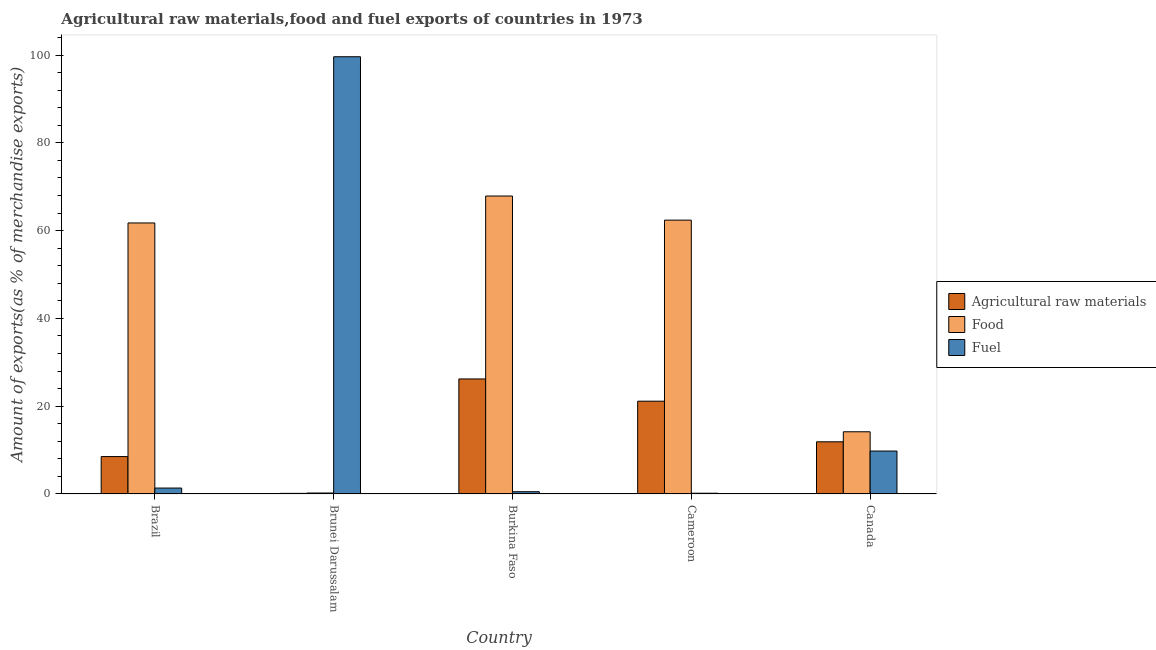How many different coloured bars are there?
Your answer should be compact. 3. Are the number of bars per tick equal to the number of legend labels?
Your answer should be very brief. Yes. Are the number of bars on each tick of the X-axis equal?
Make the answer very short. Yes. How many bars are there on the 1st tick from the left?
Your answer should be compact. 3. What is the label of the 3rd group of bars from the left?
Keep it short and to the point. Burkina Faso. In how many cases, is the number of bars for a given country not equal to the number of legend labels?
Ensure brevity in your answer.  0. What is the percentage of raw materials exports in Brunei Darussalam?
Your response must be concise. 0.14. Across all countries, what is the maximum percentage of food exports?
Ensure brevity in your answer.  67.88. Across all countries, what is the minimum percentage of food exports?
Give a very brief answer. 0.22. In which country was the percentage of food exports maximum?
Make the answer very short. Burkina Faso. In which country was the percentage of raw materials exports minimum?
Your answer should be compact. Brunei Darussalam. What is the total percentage of raw materials exports in the graph?
Your response must be concise. 67.89. What is the difference between the percentage of raw materials exports in Brunei Darussalam and that in Cameroon?
Make the answer very short. -21. What is the difference between the percentage of food exports in Brunei Darussalam and the percentage of raw materials exports in Brazil?
Offer a terse response. -8.3. What is the average percentage of fuel exports per country?
Provide a short and direct response. 22.29. What is the difference between the percentage of fuel exports and percentage of raw materials exports in Cameroon?
Give a very brief answer. -20.97. In how many countries, is the percentage of raw materials exports greater than 20 %?
Offer a very short reply. 2. What is the ratio of the percentage of food exports in Brazil to that in Brunei Darussalam?
Ensure brevity in your answer.  283.7. Is the difference between the percentage of raw materials exports in Brazil and Burkina Faso greater than the difference between the percentage of fuel exports in Brazil and Burkina Faso?
Ensure brevity in your answer.  No. What is the difference between the highest and the second highest percentage of fuel exports?
Provide a succinct answer. 89.83. What is the difference between the highest and the lowest percentage of food exports?
Ensure brevity in your answer.  67.66. In how many countries, is the percentage of food exports greater than the average percentage of food exports taken over all countries?
Give a very brief answer. 3. Is the sum of the percentage of food exports in Brazil and Canada greater than the maximum percentage of fuel exports across all countries?
Provide a short and direct response. No. What does the 3rd bar from the left in Brazil represents?
Provide a succinct answer. Fuel. What does the 2nd bar from the right in Canada represents?
Make the answer very short. Food. Is it the case that in every country, the sum of the percentage of raw materials exports and percentage of food exports is greater than the percentage of fuel exports?
Provide a succinct answer. No. How many bars are there?
Your answer should be very brief. 15. Are all the bars in the graph horizontal?
Make the answer very short. No. What is the difference between two consecutive major ticks on the Y-axis?
Make the answer very short. 20. Are the values on the major ticks of Y-axis written in scientific E-notation?
Make the answer very short. No. Does the graph contain any zero values?
Your answer should be very brief. No. Does the graph contain grids?
Offer a very short reply. No. Where does the legend appear in the graph?
Give a very brief answer. Center right. How many legend labels are there?
Make the answer very short. 3. What is the title of the graph?
Offer a very short reply. Agricultural raw materials,food and fuel exports of countries in 1973. What is the label or title of the Y-axis?
Your answer should be very brief. Amount of exports(as % of merchandise exports). What is the Amount of exports(as % of merchandise exports) in Agricultural raw materials in Brazil?
Offer a very short reply. 8.52. What is the Amount of exports(as % of merchandise exports) in Food in Brazil?
Provide a short and direct response. 61.74. What is the Amount of exports(as % of merchandise exports) in Fuel in Brazil?
Your answer should be compact. 1.35. What is the Amount of exports(as % of merchandise exports) of Agricultural raw materials in Brunei Darussalam?
Your answer should be very brief. 0.14. What is the Amount of exports(as % of merchandise exports) of Food in Brunei Darussalam?
Your response must be concise. 0.22. What is the Amount of exports(as % of merchandise exports) of Fuel in Brunei Darussalam?
Offer a very short reply. 99.61. What is the Amount of exports(as % of merchandise exports) in Agricultural raw materials in Burkina Faso?
Provide a short and direct response. 26.21. What is the Amount of exports(as % of merchandise exports) of Food in Burkina Faso?
Your answer should be compact. 67.88. What is the Amount of exports(as % of merchandise exports) in Fuel in Burkina Faso?
Your answer should be very brief. 0.52. What is the Amount of exports(as % of merchandise exports) in Agricultural raw materials in Cameroon?
Make the answer very short. 21.14. What is the Amount of exports(as % of merchandise exports) in Food in Cameroon?
Your answer should be compact. 62.39. What is the Amount of exports(as % of merchandise exports) in Fuel in Cameroon?
Make the answer very short. 0.17. What is the Amount of exports(as % of merchandise exports) in Agricultural raw materials in Canada?
Provide a succinct answer. 11.88. What is the Amount of exports(as % of merchandise exports) in Food in Canada?
Offer a terse response. 14.17. What is the Amount of exports(as % of merchandise exports) in Fuel in Canada?
Make the answer very short. 9.78. Across all countries, what is the maximum Amount of exports(as % of merchandise exports) of Agricultural raw materials?
Provide a succinct answer. 26.21. Across all countries, what is the maximum Amount of exports(as % of merchandise exports) in Food?
Offer a very short reply. 67.88. Across all countries, what is the maximum Amount of exports(as % of merchandise exports) in Fuel?
Your answer should be compact. 99.61. Across all countries, what is the minimum Amount of exports(as % of merchandise exports) of Agricultural raw materials?
Make the answer very short. 0.14. Across all countries, what is the minimum Amount of exports(as % of merchandise exports) in Food?
Make the answer very short. 0.22. Across all countries, what is the minimum Amount of exports(as % of merchandise exports) in Fuel?
Provide a succinct answer. 0.17. What is the total Amount of exports(as % of merchandise exports) in Agricultural raw materials in the graph?
Make the answer very short. 67.89. What is the total Amount of exports(as % of merchandise exports) in Food in the graph?
Keep it short and to the point. 206.4. What is the total Amount of exports(as % of merchandise exports) in Fuel in the graph?
Provide a succinct answer. 111.43. What is the difference between the Amount of exports(as % of merchandise exports) of Agricultural raw materials in Brazil and that in Brunei Darussalam?
Ensure brevity in your answer.  8.38. What is the difference between the Amount of exports(as % of merchandise exports) of Food in Brazil and that in Brunei Darussalam?
Your answer should be compact. 61.53. What is the difference between the Amount of exports(as % of merchandise exports) of Fuel in Brazil and that in Brunei Darussalam?
Offer a terse response. -98.27. What is the difference between the Amount of exports(as % of merchandise exports) of Agricultural raw materials in Brazil and that in Burkina Faso?
Your response must be concise. -17.69. What is the difference between the Amount of exports(as % of merchandise exports) of Food in Brazil and that in Burkina Faso?
Offer a very short reply. -6.14. What is the difference between the Amount of exports(as % of merchandise exports) of Fuel in Brazil and that in Burkina Faso?
Provide a succinct answer. 0.83. What is the difference between the Amount of exports(as % of merchandise exports) of Agricultural raw materials in Brazil and that in Cameroon?
Provide a succinct answer. -12.62. What is the difference between the Amount of exports(as % of merchandise exports) of Food in Brazil and that in Cameroon?
Keep it short and to the point. -0.64. What is the difference between the Amount of exports(as % of merchandise exports) of Fuel in Brazil and that in Cameroon?
Your answer should be very brief. 1.18. What is the difference between the Amount of exports(as % of merchandise exports) of Agricultural raw materials in Brazil and that in Canada?
Provide a succinct answer. -3.36. What is the difference between the Amount of exports(as % of merchandise exports) in Food in Brazil and that in Canada?
Offer a very short reply. 47.57. What is the difference between the Amount of exports(as % of merchandise exports) of Fuel in Brazil and that in Canada?
Keep it short and to the point. -8.43. What is the difference between the Amount of exports(as % of merchandise exports) of Agricultural raw materials in Brunei Darussalam and that in Burkina Faso?
Give a very brief answer. -26.07. What is the difference between the Amount of exports(as % of merchandise exports) in Food in Brunei Darussalam and that in Burkina Faso?
Your answer should be very brief. -67.66. What is the difference between the Amount of exports(as % of merchandise exports) of Fuel in Brunei Darussalam and that in Burkina Faso?
Keep it short and to the point. 99.1. What is the difference between the Amount of exports(as % of merchandise exports) in Agricultural raw materials in Brunei Darussalam and that in Cameroon?
Your answer should be compact. -21. What is the difference between the Amount of exports(as % of merchandise exports) in Food in Brunei Darussalam and that in Cameroon?
Offer a very short reply. -62.17. What is the difference between the Amount of exports(as % of merchandise exports) of Fuel in Brunei Darussalam and that in Cameroon?
Offer a terse response. 99.44. What is the difference between the Amount of exports(as % of merchandise exports) of Agricultural raw materials in Brunei Darussalam and that in Canada?
Offer a very short reply. -11.75. What is the difference between the Amount of exports(as % of merchandise exports) in Food in Brunei Darussalam and that in Canada?
Your response must be concise. -13.95. What is the difference between the Amount of exports(as % of merchandise exports) in Fuel in Brunei Darussalam and that in Canada?
Make the answer very short. 89.83. What is the difference between the Amount of exports(as % of merchandise exports) in Agricultural raw materials in Burkina Faso and that in Cameroon?
Give a very brief answer. 5.07. What is the difference between the Amount of exports(as % of merchandise exports) in Food in Burkina Faso and that in Cameroon?
Make the answer very short. 5.49. What is the difference between the Amount of exports(as % of merchandise exports) of Fuel in Burkina Faso and that in Cameroon?
Your answer should be compact. 0.35. What is the difference between the Amount of exports(as % of merchandise exports) of Agricultural raw materials in Burkina Faso and that in Canada?
Make the answer very short. 14.32. What is the difference between the Amount of exports(as % of merchandise exports) in Food in Burkina Faso and that in Canada?
Your answer should be compact. 53.71. What is the difference between the Amount of exports(as % of merchandise exports) of Fuel in Burkina Faso and that in Canada?
Offer a very short reply. -9.27. What is the difference between the Amount of exports(as % of merchandise exports) of Agricultural raw materials in Cameroon and that in Canada?
Provide a succinct answer. 9.25. What is the difference between the Amount of exports(as % of merchandise exports) of Food in Cameroon and that in Canada?
Keep it short and to the point. 48.22. What is the difference between the Amount of exports(as % of merchandise exports) in Fuel in Cameroon and that in Canada?
Your response must be concise. -9.61. What is the difference between the Amount of exports(as % of merchandise exports) of Agricultural raw materials in Brazil and the Amount of exports(as % of merchandise exports) of Food in Brunei Darussalam?
Give a very brief answer. 8.3. What is the difference between the Amount of exports(as % of merchandise exports) of Agricultural raw materials in Brazil and the Amount of exports(as % of merchandise exports) of Fuel in Brunei Darussalam?
Ensure brevity in your answer.  -91.09. What is the difference between the Amount of exports(as % of merchandise exports) of Food in Brazil and the Amount of exports(as % of merchandise exports) of Fuel in Brunei Darussalam?
Provide a short and direct response. -37.87. What is the difference between the Amount of exports(as % of merchandise exports) in Agricultural raw materials in Brazil and the Amount of exports(as % of merchandise exports) in Food in Burkina Faso?
Your answer should be compact. -59.36. What is the difference between the Amount of exports(as % of merchandise exports) in Agricultural raw materials in Brazil and the Amount of exports(as % of merchandise exports) in Fuel in Burkina Faso?
Offer a terse response. 8.01. What is the difference between the Amount of exports(as % of merchandise exports) in Food in Brazil and the Amount of exports(as % of merchandise exports) in Fuel in Burkina Faso?
Your response must be concise. 61.23. What is the difference between the Amount of exports(as % of merchandise exports) in Agricultural raw materials in Brazil and the Amount of exports(as % of merchandise exports) in Food in Cameroon?
Give a very brief answer. -53.87. What is the difference between the Amount of exports(as % of merchandise exports) of Agricultural raw materials in Brazil and the Amount of exports(as % of merchandise exports) of Fuel in Cameroon?
Ensure brevity in your answer.  8.35. What is the difference between the Amount of exports(as % of merchandise exports) of Food in Brazil and the Amount of exports(as % of merchandise exports) of Fuel in Cameroon?
Give a very brief answer. 61.57. What is the difference between the Amount of exports(as % of merchandise exports) in Agricultural raw materials in Brazil and the Amount of exports(as % of merchandise exports) in Food in Canada?
Ensure brevity in your answer.  -5.65. What is the difference between the Amount of exports(as % of merchandise exports) in Agricultural raw materials in Brazil and the Amount of exports(as % of merchandise exports) in Fuel in Canada?
Your answer should be compact. -1.26. What is the difference between the Amount of exports(as % of merchandise exports) of Food in Brazil and the Amount of exports(as % of merchandise exports) of Fuel in Canada?
Provide a short and direct response. 51.96. What is the difference between the Amount of exports(as % of merchandise exports) of Agricultural raw materials in Brunei Darussalam and the Amount of exports(as % of merchandise exports) of Food in Burkina Faso?
Your answer should be compact. -67.74. What is the difference between the Amount of exports(as % of merchandise exports) of Agricultural raw materials in Brunei Darussalam and the Amount of exports(as % of merchandise exports) of Fuel in Burkina Faso?
Your answer should be compact. -0.38. What is the difference between the Amount of exports(as % of merchandise exports) in Food in Brunei Darussalam and the Amount of exports(as % of merchandise exports) in Fuel in Burkina Faso?
Ensure brevity in your answer.  -0.3. What is the difference between the Amount of exports(as % of merchandise exports) in Agricultural raw materials in Brunei Darussalam and the Amount of exports(as % of merchandise exports) in Food in Cameroon?
Your answer should be compact. -62.25. What is the difference between the Amount of exports(as % of merchandise exports) in Agricultural raw materials in Brunei Darussalam and the Amount of exports(as % of merchandise exports) in Fuel in Cameroon?
Offer a very short reply. -0.03. What is the difference between the Amount of exports(as % of merchandise exports) of Food in Brunei Darussalam and the Amount of exports(as % of merchandise exports) of Fuel in Cameroon?
Give a very brief answer. 0.05. What is the difference between the Amount of exports(as % of merchandise exports) of Agricultural raw materials in Brunei Darussalam and the Amount of exports(as % of merchandise exports) of Food in Canada?
Offer a very short reply. -14.04. What is the difference between the Amount of exports(as % of merchandise exports) of Agricultural raw materials in Brunei Darussalam and the Amount of exports(as % of merchandise exports) of Fuel in Canada?
Make the answer very short. -9.64. What is the difference between the Amount of exports(as % of merchandise exports) of Food in Brunei Darussalam and the Amount of exports(as % of merchandise exports) of Fuel in Canada?
Your answer should be very brief. -9.56. What is the difference between the Amount of exports(as % of merchandise exports) in Agricultural raw materials in Burkina Faso and the Amount of exports(as % of merchandise exports) in Food in Cameroon?
Make the answer very short. -36.18. What is the difference between the Amount of exports(as % of merchandise exports) of Agricultural raw materials in Burkina Faso and the Amount of exports(as % of merchandise exports) of Fuel in Cameroon?
Keep it short and to the point. 26.04. What is the difference between the Amount of exports(as % of merchandise exports) in Food in Burkina Faso and the Amount of exports(as % of merchandise exports) in Fuel in Cameroon?
Offer a very short reply. 67.71. What is the difference between the Amount of exports(as % of merchandise exports) of Agricultural raw materials in Burkina Faso and the Amount of exports(as % of merchandise exports) of Food in Canada?
Keep it short and to the point. 12.04. What is the difference between the Amount of exports(as % of merchandise exports) of Agricultural raw materials in Burkina Faso and the Amount of exports(as % of merchandise exports) of Fuel in Canada?
Offer a very short reply. 16.43. What is the difference between the Amount of exports(as % of merchandise exports) of Food in Burkina Faso and the Amount of exports(as % of merchandise exports) of Fuel in Canada?
Provide a short and direct response. 58.1. What is the difference between the Amount of exports(as % of merchandise exports) of Agricultural raw materials in Cameroon and the Amount of exports(as % of merchandise exports) of Food in Canada?
Give a very brief answer. 6.97. What is the difference between the Amount of exports(as % of merchandise exports) of Agricultural raw materials in Cameroon and the Amount of exports(as % of merchandise exports) of Fuel in Canada?
Make the answer very short. 11.36. What is the difference between the Amount of exports(as % of merchandise exports) of Food in Cameroon and the Amount of exports(as % of merchandise exports) of Fuel in Canada?
Offer a very short reply. 52.61. What is the average Amount of exports(as % of merchandise exports) of Agricultural raw materials per country?
Make the answer very short. 13.58. What is the average Amount of exports(as % of merchandise exports) in Food per country?
Your response must be concise. 41.28. What is the average Amount of exports(as % of merchandise exports) of Fuel per country?
Your answer should be very brief. 22.29. What is the difference between the Amount of exports(as % of merchandise exports) in Agricultural raw materials and Amount of exports(as % of merchandise exports) in Food in Brazil?
Keep it short and to the point. -53.22. What is the difference between the Amount of exports(as % of merchandise exports) in Agricultural raw materials and Amount of exports(as % of merchandise exports) in Fuel in Brazil?
Your response must be concise. 7.17. What is the difference between the Amount of exports(as % of merchandise exports) in Food and Amount of exports(as % of merchandise exports) in Fuel in Brazil?
Offer a terse response. 60.4. What is the difference between the Amount of exports(as % of merchandise exports) of Agricultural raw materials and Amount of exports(as % of merchandise exports) of Food in Brunei Darussalam?
Offer a terse response. -0.08. What is the difference between the Amount of exports(as % of merchandise exports) in Agricultural raw materials and Amount of exports(as % of merchandise exports) in Fuel in Brunei Darussalam?
Provide a short and direct response. -99.48. What is the difference between the Amount of exports(as % of merchandise exports) of Food and Amount of exports(as % of merchandise exports) of Fuel in Brunei Darussalam?
Give a very brief answer. -99.4. What is the difference between the Amount of exports(as % of merchandise exports) in Agricultural raw materials and Amount of exports(as % of merchandise exports) in Food in Burkina Faso?
Ensure brevity in your answer.  -41.67. What is the difference between the Amount of exports(as % of merchandise exports) in Agricultural raw materials and Amount of exports(as % of merchandise exports) in Fuel in Burkina Faso?
Make the answer very short. 25.69. What is the difference between the Amount of exports(as % of merchandise exports) of Food and Amount of exports(as % of merchandise exports) of Fuel in Burkina Faso?
Your answer should be compact. 67.36. What is the difference between the Amount of exports(as % of merchandise exports) in Agricultural raw materials and Amount of exports(as % of merchandise exports) in Food in Cameroon?
Provide a succinct answer. -41.25. What is the difference between the Amount of exports(as % of merchandise exports) of Agricultural raw materials and Amount of exports(as % of merchandise exports) of Fuel in Cameroon?
Your response must be concise. 20.97. What is the difference between the Amount of exports(as % of merchandise exports) in Food and Amount of exports(as % of merchandise exports) in Fuel in Cameroon?
Your answer should be very brief. 62.22. What is the difference between the Amount of exports(as % of merchandise exports) in Agricultural raw materials and Amount of exports(as % of merchandise exports) in Food in Canada?
Ensure brevity in your answer.  -2.29. What is the difference between the Amount of exports(as % of merchandise exports) of Agricultural raw materials and Amount of exports(as % of merchandise exports) of Fuel in Canada?
Give a very brief answer. 2.1. What is the difference between the Amount of exports(as % of merchandise exports) of Food and Amount of exports(as % of merchandise exports) of Fuel in Canada?
Provide a short and direct response. 4.39. What is the ratio of the Amount of exports(as % of merchandise exports) in Agricultural raw materials in Brazil to that in Brunei Darussalam?
Keep it short and to the point. 62.58. What is the ratio of the Amount of exports(as % of merchandise exports) of Food in Brazil to that in Brunei Darussalam?
Provide a succinct answer. 283.7. What is the ratio of the Amount of exports(as % of merchandise exports) in Fuel in Brazil to that in Brunei Darussalam?
Keep it short and to the point. 0.01. What is the ratio of the Amount of exports(as % of merchandise exports) in Agricultural raw materials in Brazil to that in Burkina Faso?
Make the answer very short. 0.33. What is the ratio of the Amount of exports(as % of merchandise exports) in Food in Brazil to that in Burkina Faso?
Your answer should be compact. 0.91. What is the ratio of the Amount of exports(as % of merchandise exports) of Fuel in Brazil to that in Burkina Faso?
Provide a succinct answer. 2.61. What is the ratio of the Amount of exports(as % of merchandise exports) in Agricultural raw materials in Brazil to that in Cameroon?
Offer a terse response. 0.4. What is the ratio of the Amount of exports(as % of merchandise exports) of Fuel in Brazil to that in Cameroon?
Your response must be concise. 7.98. What is the ratio of the Amount of exports(as % of merchandise exports) in Agricultural raw materials in Brazil to that in Canada?
Make the answer very short. 0.72. What is the ratio of the Amount of exports(as % of merchandise exports) of Food in Brazil to that in Canada?
Give a very brief answer. 4.36. What is the ratio of the Amount of exports(as % of merchandise exports) of Fuel in Brazil to that in Canada?
Your response must be concise. 0.14. What is the ratio of the Amount of exports(as % of merchandise exports) of Agricultural raw materials in Brunei Darussalam to that in Burkina Faso?
Your response must be concise. 0.01. What is the ratio of the Amount of exports(as % of merchandise exports) of Food in Brunei Darussalam to that in Burkina Faso?
Keep it short and to the point. 0. What is the ratio of the Amount of exports(as % of merchandise exports) in Fuel in Brunei Darussalam to that in Burkina Faso?
Your answer should be very brief. 193.2. What is the ratio of the Amount of exports(as % of merchandise exports) in Agricultural raw materials in Brunei Darussalam to that in Cameroon?
Make the answer very short. 0.01. What is the ratio of the Amount of exports(as % of merchandise exports) of Food in Brunei Darussalam to that in Cameroon?
Offer a terse response. 0. What is the ratio of the Amount of exports(as % of merchandise exports) of Fuel in Brunei Darussalam to that in Cameroon?
Offer a very short reply. 589.81. What is the ratio of the Amount of exports(as % of merchandise exports) of Agricultural raw materials in Brunei Darussalam to that in Canada?
Ensure brevity in your answer.  0.01. What is the ratio of the Amount of exports(as % of merchandise exports) of Food in Brunei Darussalam to that in Canada?
Provide a short and direct response. 0.02. What is the ratio of the Amount of exports(as % of merchandise exports) in Fuel in Brunei Darussalam to that in Canada?
Keep it short and to the point. 10.18. What is the ratio of the Amount of exports(as % of merchandise exports) in Agricultural raw materials in Burkina Faso to that in Cameroon?
Offer a very short reply. 1.24. What is the ratio of the Amount of exports(as % of merchandise exports) of Food in Burkina Faso to that in Cameroon?
Offer a very short reply. 1.09. What is the ratio of the Amount of exports(as % of merchandise exports) in Fuel in Burkina Faso to that in Cameroon?
Provide a succinct answer. 3.05. What is the ratio of the Amount of exports(as % of merchandise exports) of Agricultural raw materials in Burkina Faso to that in Canada?
Offer a terse response. 2.21. What is the ratio of the Amount of exports(as % of merchandise exports) in Food in Burkina Faso to that in Canada?
Offer a very short reply. 4.79. What is the ratio of the Amount of exports(as % of merchandise exports) of Fuel in Burkina Faso to that in Canada?
Provide a short and direct response. 0.05. What is the ratio of the Amount of exports(as % of merchandise exports) in Agricultural raw materials in Cameroon to that in Canada?
Ensure brevity in your answer.  1.78. What is the ratio of the Amount of exports(as % of merchandise exports) in Food in Cameroon to that in Canada?
Give a very brief answer. 4.4. What is the ratio of the Amount of exports(as % of merchandise exports) in Fuel in Cameroon to that in Canada?
Your response must be concise. 0.02. What is the difference between the highest and the second highest Amount of exports(as % of merchandise exports) of Agricultural raw materials?
Ensure brevity in your answer.  5.07. What is the difference between the highest and the second highest Amount of exports(as % of merchandise exports) in Food?
Offer a very short reply. 5.49. What is the difference between the highest and the second highest Amount of exports(as % of merchandise exports) of Fuel?
Provide a short and direct response. 89.83. What is the difference between the highest and the lowest Amount of exports(as % of merchandise exports) in Agricultural raw materials?
Your answer should be very brief. 26.07. What is the difference between the highest and the lowest Amount of exports(as % of merchandise exports) in Food?
Your response must be concise. 67.66. What is the difference between the highest and the lowest Amount of exports(as % of merchandise exports) in Fuel?
Offer a terse response. 99.44. 